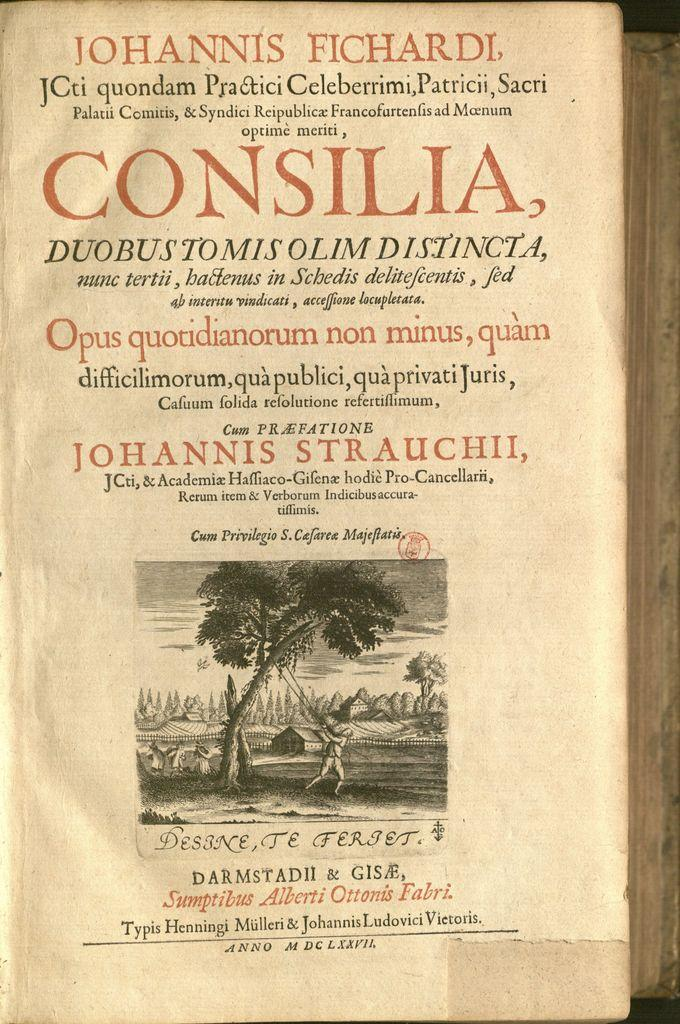<image>
Write a terse but informative summary of the picture. old book about johannis strauchii, in another language 